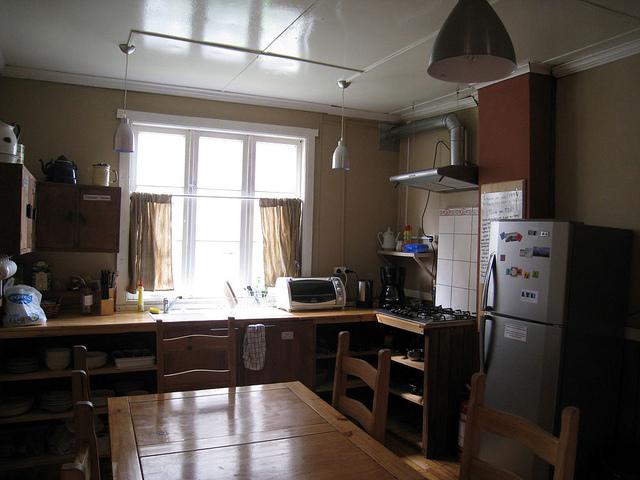Where is the wine glass?
Answer briefly. N/a. How many lights are on?
Keep it brief. 0. Is there enough light in this room?
Quick response, please. Yes. Is there a chandelier above the dining table?
Answer briefly. No. What is on the ceiling?
Keep it brief. Lights. What is the primary color of the room?
Concise answer only. Brown. What room is this?
Be succinct. Kitchen. Is the ceiling flat?
Keep it brief. Yes. How many people can be seated at the table?
Short answer required. 6. Are there any lights on?
Concise answer only. No. What color is the curtain in the hallway?
Be succinct. Brown. What is missing from the stove?
Short answer required. Oven. Does this room have enough carpeting?
Give a very brief answer. No. How many window panes are they?
Short answer required. 3. Where are the glasses kept?
Concise answer only. Cupboard. Are the cabinets closed?
Quick response, please. Yes. How many walls have windows?
Keep it brief. 1. Is this a gas or electric stove?
Give a very brief answer. Gas. How many lights are hanging from the ceiling?
Keep it brief. 3. 